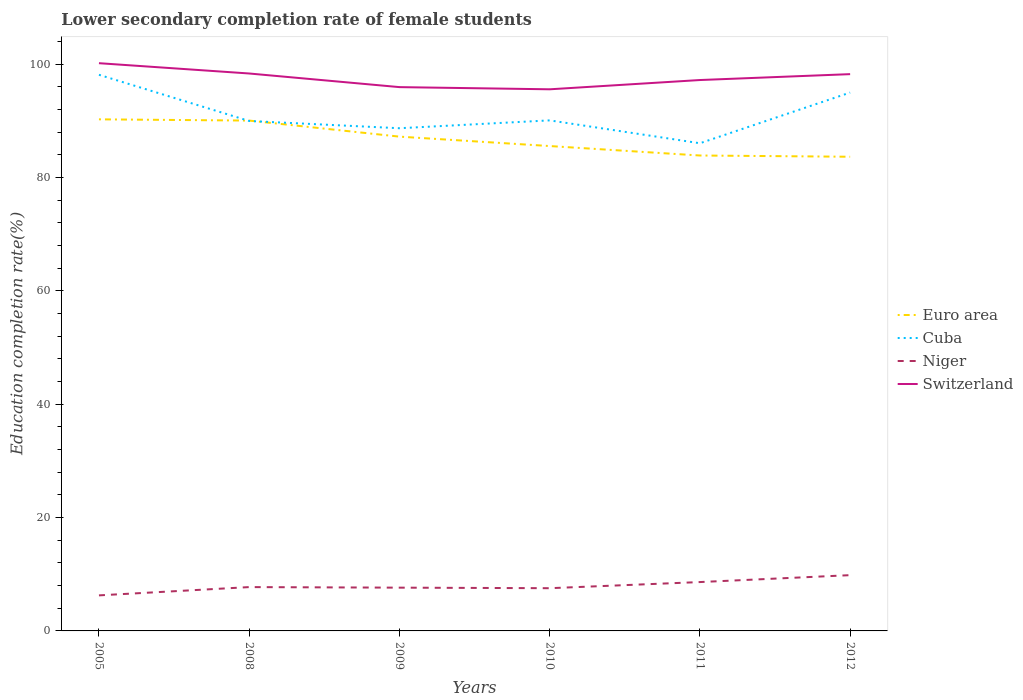How many different coloured lines are there?
Give a very brief answer. 4. Does the line corresponding to Cuba intersect with the line corresponding to Switzerland?
Your answer should be very brief. No. Is the number of lines equal to the number of legend labels?
Make the answer very short. Yes. Across all years, what is the maximum lower secondary completion rate of female students in Switzerland?
Your answer should be very brief. 95.54. In which year was the lower secondary completion rate of female students in Euro area maximum?
Your answer should be compact. 2012. What is the total lower secondary completion rate of female students in Cuba in the graph?
Your response must be concise. 2.65. What is the difference between the highest and the second highest lower secondary completion rate of female students in Niger?
Ensure brevity in your answer.  3.57. Does the graph contain any zero values?
Ensure brevity in your answer.  No. How many legend labels are there?
Your answer should be very brief. 4. What is the title of the graph?
Give a very brief answer. Lower secondary completion rate of female students. What is the label or title of the X-axis?
Provide a succinct answer. Years. What is the label or title of the Y-axis?
Provide a succinct answer. Education completion rate(%). What is the Education completion rate(%) in Euro area in 2005?
Make the answer very short. 90.25. What is the Education completion rate(%) of Cuba in 2005?
Offer a very short reply. 98.11. What is the Education completion rate(%) of Niger in 2005?
Offer a very short reply. 6.27. What is the Education completion rate(%) in Switzerland in 2005?
Your answer should be compact. 100.15. What is the Education completion rate(%) of Euro area in 2008?
Your answer should be compact. 90.03. What is the Education completion rate(%) in Cuba in 2008?
Your answer should be compact. 89.95. What is the Education completion rate(%) in Niger in 2008?
Your answer should be compact. 7.73. What is the Education completion rate(%) of Switzerland in 2008?
Offer a very short reply. 98.33. What is the Education completion rate(%) of Euro area in 2009?
Make the answer very short. 87.19. What is the Education completion rate(%) of Cuba in 2009?
Provide a short and direct response. 88.68. What is the Education completion rate(%) in Niger in 2009?
Your answer should be very brief. 7.63. What is the Education completion rate(%) in Switzerland in 2009?
Provide a succinct answer. 95.93. What is the Education completion rate(%) in Euro area in 2010?
Offer a very short reply. 85.53. What is the Education completion rate(%) in Cuba in 2010?
Ensure brevity in your answer.  90.06. What is the Education completion rate(%) in Niger in 2010?
Provide a succinct answer. 7.54. What is the Education completion rate(%) in Switzerland in 2010?
Make the answer very short. 95.54. What is the Education completion rate(%) in Euro area in 2011?
Your answer should be very brief. 83.87. What is the Education completion rate(%) of Cuba in 2011?
Your answer should be very brief. 86.03. What is the Education completion rate(%) in Niger in 2011?
Your answer should be compact. 8.62. What is the Education completion rate(%) in Switzerland in 2011?
Make the answer very short. 97.18. What is the Education completion rate(%) in Euro area in 2012?
Make the answer very short. 83.65. What is the Education completion rate(%) of Cuba in 2012?
Provide a short and direct response. 94.97. What is the Education completion rate(%) in Niger in 2012?
Provide a short and direct response. 9.84. What is the Education completion rate(%) of Switzerland in 2012?
Provide a succinct answer. 98.22. Across all years, what is the maximum Education completion rate(%) of Euro area?
Your answer should be very brief. 90.25. Across all years, what is the maximum Education completion rate(%) of Cuba?
Provide a short and direct response. 98.11. Across all years, what is the maximum Education completion rate(%) of Niger?
Provide a succinct answer. 9.84. Across all years, what is the maximum Education completion rate(%) of Switzerland?
Ensure brevity in your answer.  100.15. Across all years, what is the minimum Education completion rate(%) in Euro area?
Provide a short and direct response. 83.65. Across all years, what is the minimum Education completion rate(%) in Cuba?
Make the answer very short. 86.03. Across all years, what is the minimum Education completion rate(%) in Niger?
Offer a terse response. 6.27. Across all years, what is the minimum Education completion rate(%) of Switzerland?
Your response must be concise. 95.54. What is the total Education completion rate(%) in Euro area in the graph?
Offer a terse response. 520.51. What is the total Education completion rate(%) of Cuba in the graph?
Your response must be concise. 547.79. What is the total Education completion rate(%) in Niger in the graph?
Offer a very short reply. 47.63. What is the total Education completion rate(%) in Switzerland in the graph?
Provide a succinct answer. 585.35. What is the difference between the Education completion rate(%) in Euro area in 2005 and that in 2008?
Keep it short and to the point. 0.22. What is the difference between the Education completion rate(%) of Cuba in 2005 and that in 2008?
Ensure brevity in your answer.  8.15. What is the difference between the Education completion rate(%) of Niger in 2005 and that in 2008?
Ensure brevity in your answer.  -1.46. What is the difference between the Education completion rate(%) of Switzerland in 2005 and that in 2008?
Keep it short and to the point. 1.82. What is the difference between the Education completion rate(%) in Euro area in 2005 and that in 2009?
Offer a very short reply. 3.05. What is the difference between the Education completion rate(%) in Cuba in 2005 and that in 2009?
Ensure brevity in your answer.  9.43. What is the difference between the Education completion rate(%) of Niger in 2005 and that in 2009?
Provide a succinct answer. -1.36. What is the difference between the Education completion rate(%) in Switzerland in 2005 and that in 2009?
Provide a succinct answer. 4.22. What is the difference between the Education completion rate(%) of Euro area in 2005 and that in 2010?
Provide a short and direct response. 4.71. What is the difference between the Education completion rate(%) in Cuba in 2005 and that in 2010?
Provide a succinct answer. 8.04. What is the difference between the Education completion rate(%) of Niger in 2005 and that in 2010?
Your response must be concise. -1.27. What is the difference between the Education completion rate(%) in Switzerland in 2005 and that in 2010?
Provide a succinct answer. 4.61. What is the difference between the Education completion rate(%) in Euro area in 2005 and that in 2011?
Keep it short and to the point. 6.38. What is the difference between the Education completion rate(%) in Cuba in 2005 and that in 2011?
Your response must be concise. 12.08. What is the difference between the Education completion rate(%) in Niger in 2005 and that in 2011?
Keep it short and to the point. -2.35. What is the difference between the Education completion rate(%) of Switzerland in 2005 and that in 2011?
Give a very brief answer. 2.97. What is the difference between the Education completion rate(%) of Euro area in 2005 and that in 2012?
Your answer should be compact. 6.6. What is the difference between the Education completion rate(%) in Cuba in 2005 and that in 2012?
Your answer should be compact. 3.14. What is the difference between the Education completion rate(%) of Niger in 2005 and that in 2012?
Your answer should be very brief. -3.57. What is the difference between the Education completion rate(%) in Switzerland in 2005 and that in 2012?
Give a very brief answer. 1.93. What is the difference between the Education completion rate(%) of Euro area in 2008 and that in 2009?
Keep it short and to the point. 2.83. What is the difference between the Education completion rate(%) of Cuba in 2008 and that in 2009?
Make the answer very short. 1.28. What is the difference between the Education completion rate(%) of Niger in 2008 and that in 2009?
Offer a terse response. 0.1. What is the difference between the Education completion rate(%) of Switzerland in 2008 and that in 2009?
Your response must be concise. 2.4. What is the difference between the Education completion rate(%) in Euro area in 2008 and that in 2010?
Provide a succinct answer. 4.49. What is the difference between the Education completion rate(%) of Cuba in 2008 and that in 2010?
Make the answer very short. -0.11. What is the difference between the Education completion rate(%) of Niger in 2008 and that in 2010?
Make the answer very short. 0.2. What is the difference between the Education completion rate(%) in Switzerland in 2008 and that in 2010?
Ensure brevity in your answer.  2.79. What is the difference between the Education completion rate(%) of Euro area in 2008 and that in 2011?
Provide a short and direct response. 6.16. What is the difference between the Education completion rate(%) of Cuba in 2008 and that in 2011?
Provide a short and direct response. 3.93. What is the difference between the Education completion rate(%) of Niger in 2008 and that in 2011?
Give a very brief answer. -0.89. What is the difference between the Education completion rate(%) of Switzerland in 2008 and that in 2011?
Provide a short and direct response. 1.15. What is the difference between the Education completion rate(%) in Euro area in 2008 and that in 2012?
Keep it short and to the point. 6.38. What is the difference between the Education completion rate(%) of Cuba in 2008 and that in 2012?
Give a very brief answer. -5.01. What is the difference between the Education completion rate(%) of Niger in 2008 and that in 2012?
Your answer should be very brief. -2.11. What is the difference between the Education completion rate(%) of Switzerland in 2008 and that in 2012?
Provide a short and direct response. 0.11. What is the difference between the Education completion rate(%) in Euro area in 2009 and that in 2010?
Provide a succinct answer. 1.66. What is the difference between the Education completion rate(%) in Cuba in 2009 and that in 2010?
Provide a succinct answer. -1.39. What is the difference between the Education completion rate(%) in Niger in 2009 and that in 2010?
Provide a short and direct response. 0.1. What is the difference between the Education completion rate(%) of Switzerland in 2009 and that in 2010?
Give a very brief answer. 0.39. What is the difference between the Education completion rate(%) of Euro area in 2009 and that in 2011?
Provide a short and direct response. 3.33. What is the difference between the Education completion rate(%) of Cuba in 2009 and that in 2011?
Give a very brief answer. 2.65. What is the difference between the Education completion rate(%) in Niger in 2009 and that in 2011?
Provide a succinct answer. -0.99. What is the difference between the Education completion rate(%) in Switzerland in 2009 and that in 2011?
Provide a succinct answer. -1.25. What is the difference between the Education completion rate(%) of Euro area in 2009 and that in 2012?
Your response must be concise. 3.55. What is the difference between the Education completion rate(%) of Cuba in 2009 and that in 2012?
Your answer should be compact. -6.29. What is the difference between the Education completion rate(%) of Niger in 2009 and that in 2012?
Your response must be concise. -2.2. What is the difference between the Education completion rate(%) of Switzerland in 2009 and that in 2012?
Make the answer very short. -2.29. What is the difference between the Education completion rate(%) of Euro area in 2010 and that in 2011?
Provide a short and direct response. 1.67. What is the difference between the Education completion rate(%) of Cuba in 2010 and that in 2011?
Your response must be concise. 4.04. What is the difference between the Education completion rate(%) in Niger in 2010 and that in 2011?
Provide a short and direct response. -1.08. What is the difference between the Education completion rate(%) of Switzerland in 2010 and that in 2011?
Your answer should be compact. -1.64. What is the difference between the Education completion rate(%) of Euro area in 2010 and that in 2012?
Your response must be concise. 1.89. What is the difference between the Education completion rate(%) of Cuba in 2010 and that in 2012?
Make the answer very short. -4.91. What is the difference between the Education completion rate(%) of Niger in 2010 and that in 2012?
Offer a very short reply. -2.3. What is the difference between the Education completion rate(%) in Switzerland in 2010 and that in 2012?
Offer a terse response. -2.67. What is the difference between the Education completion rate(%) in Euro area in 2011 and that in 2012?
Your response must be concise. 0.22. What is the difference between the Education completion rate(%) in Cuba in 2011 and that in 2012?
Provide a short and direct response. -8.94. What is the difference between the Education completion rate(%) in Niger in 2011 and that in 2012?
Ensure brevity in your answer.  -1.22. What is the difference between the Education completion rate(%) in Switzerland in 2011 and that in 2012?
Provide a short and direct response. -1.04. What is the difference between the Education completion rate(%) of Euro area in 2005 and the Education completion rate(%) of Cuba in 2008?
Make the answer very short. 0.29. What is the difference between the Education completion rate(%) of Euro area in 2005 and the Education completion rate(%) of Niger in 2008?
Make the answer very short. 82.51. What is the difference between the Education completion rate(%) in Euro area in 2005 and the Education completion rate(%) in Switzerland in 2008?
Make the answer very short. -8.09. What is the difference between the Education completion rate(%) in Cuba in 2005 and the Education completion rate(%) in Niger in 2008?
Keep it short and to the point. 90.37. What is the difference between the Education completion rate(%) in Cuba in 2005 and the Education completion rate(%) in Switzerland in 2008?
Offer a terse response. -0.23. What is the difference between the Education completion rate(%) of Niger in 2005 and the Education completion rate(%) of Switzerland in 2008?
Ensure brevity in your answer.  -92.06. What is the difference between the Education completion rate(%) of Euro area in 2005 and the Education completion rate(%) of Cuba in 2009?
Provide a short and direct response. 1.57. What is the difference between the Education completion rate(%) of Euro area in 2005 and the Education completion rate(%) of Niger in 2009?
Your answer should be very brief. 82.61. What is the difference between the Education completion rate(%) in Euro area in 2005 and the Education completion rate(%) in Switzerland in 2009?
Your answer should be very brief. -5.68. What is the difference between the Education completion rate(%) in Cuba in 2005 and the Education completion rate(%) in Niger in 2009?
Keep it short and to the point. 90.47. What is the difference between the Education completion rate(%) of Cuba in 2005 and the Education completion rate(%) of Switzerland in 2009?
Your response must be concise. 2.18. What is the difference between the Education completion rate(%) in Niger in 2005 and the Education completion rate(%) in Switzerland in 2009?
Your response must be concise. -89.66. What is the difference between the Education completion rate(%) of Euro area in 2005 and the Education completion rate(%) of Cuba in 2010?
Offer a very short reply. 0.18. What is the difference between the Education completion rate(%) of Euro area in 2005 and the Education completion rate(%) of Niger in 2010?
Keep it short and to the point. 82.71. What is the difference between the Education completion rate(%) in Euro area in 2005 and the Education completion rate(%) in Switzerland in 2010?
Keep it short and to the point. -5.3. What is the difference between the Education completion rate(%) in Cuba in 2005 and the Education completion rate(%) in Niger in 2010?
Your response must be concise. 90.57. What is the difference between the Education completion rate(%) of Cuba in 2005 and the Education completion rate(%) of Switzerland in 2010?
Your response must be concise. 2.56. What is the difference between the Education completion rate(%) of Niger in 2005 and the Education completion rate(%) of Switzerland in 2010?
Provide a succinct answer. -89.27. What is the difference between the Education completion rate(%) in Euro area in 2005 and the Education completion rate(%) in Cuba in 2011?
Your answer should be compact. 4.22. What is the difference between the Education completion rate(%) in Euro area in 2005 and the Education completion rate(%) in Niger in 2011?
Offer a terse response. 81.63. What is the difference between the Education completion rate(%) in Euro area in 2005 and the Education completion rate(%) in Switzerland in 2011?
Your response must be concise. -6.93. What is the difference between the Education completion rate(%) in Cuba in 2005 and the Education completion rate(%) in Niger in 2011?
Make the answer very short. 89.49. What is the difference between the Education completion rate(%) in Cuba in 2005 and the Education completion rate(%) in Switzerland in 2011?
Your answer should be very brief. 0.93. What is the difference between the Education completion rate(%) of Niger in 2005 and the Education completion rate(%) of Switzerland in 2011?
Your response must be concise. -90.91. What is the difference between the Education completion rate(%) in Euro area in 2005 and the Education completion rate(%) in Cuba in 2012?
Your response must be concise. -4.72. What is the difference between the Education completion rate(%) in Euro area in 2005 and the Education completion rate(%) in Niger in 2012?
Make the answer very short. 80.41. What is the difference between the Education completion rate(%) in Euro area in 2005 and the Education completion rate(%) in Switzerland in 2012?
Keep it short and to the point. -7.97. What is the difference between the Education completion rate(%) in Cuba in 2005 and the Education completion rate(%) in Niger in 2012?
Your response must be concise. 88.27. What is the difference between the Education completion rate(%) in Cuba in 2005 and the Education completion rate(%) in Switzerland in 2012?
Ensure brevity in your answer.  -0.11. What is the difference between the Education completion rate(%) in Niger in 2005 and the Education completion rate(%) in Switzerland in 2012?
Your answer should be compact. -91.95. What is the difference between the Education completion rate(%) in Euro area in 2008 and the Education completion rate(%) in Cuba in 2009?
Provide a short and direct response. 1.35. What is the difference between the Education completion rate(%) in Euro area in 2008 and the Education completion rate(%) in Niger in 2009?
Offer a very short reply. 82.39. What is the difference between the Education completion rate(%) in Euro area in 2008 and the Education completion rate(%) in Switzerland in 2009?
Give a very brief answer. -5.9. What is the difference between the Education completion rate(%) of Cuba in 2008 and the Education completion rate(%) of Niger in 2009?
Give a very brief answer. 82.32. What is the difference between the Education completion rate(%) in Cuba in 2008 and the Education completion rate(%) in Switzerland in 2009?
Keep it short and to the point. -5.97. What is the difference between the Education completion rate(%) of Niger in 2008 and the Education completion rate(%) of Switzerland in 2009?
Your answer should be compact. -88.2. What is the difference between the Education completion rate(%) of Euro area in 2008 and the Education completion rate(%) of Cuba in 2010?
Your answer should be very brief. -0.04. What is the difference between the Education completion rate(%) in Euro area in 2008 and the Education completion rate(%) in Niger in 2010?
Offer a very short reply. 82.49. What is the difference between the Education completion rate(%) in Euro area in 2008 and the Education completion rate(%) in Switzerland in 2010?
Your answer should be very brief. -5.52. What is the difference between the Education completion rate(%) in Cuba in 2008 and the Education completion rate(%) in Niger in 2010?
Keep it short and to the point. 82.42. What is the difference between the Education completion rate(%) in Cuba in 2008 and the Education completion rate(%) in Switzerland in 2010?
Keep it short and to the point. -5.59. What is the difference between the Education completion rate(%) in Niger in 2008 and the Education completion rate(%) in Switzerland in 2010?
Give a very brief answer. -87.81. What is the difference between the Education completion rate(%) in Euro area in 2008 and the Education completion rate(%) in Niger in 2011?
Ensure brevity in your answer.  81.41. What is the difference between the Education completion rate(%) in Euro area in 2008 and the Education completion rate(%) in Switzerland in 2011?
Your response must be concise. -7.15. What is the difference between the Education completion rate(%) of Cuba in 2008 and the Education completion rate(%) of Niger in 2011?
Your response must be concise. 81.34. What is the difference between the Education completion rate(%) of Cuba in 2008 and the Education completion rate(%) of Switzerland in 2011?
Keep it short and to the point. -7.22. What is the difference between the Education completion rate(%) in Niger in 2008 and the Education completion rate(%) in Switzerland in 2011?
Make the answer very short. -89.45. What is the difference between the Education completion rate(%) of Euro area in 2008 and the Education completion rate(%) of Cuba in 2012?
Make the answer very short. -4.94. What is the difference between the Education completion rate(%) of Euro area in 2008 and the Education completion rate(%) of Niger in 2012?
Provide a succinct answer. 80.19. What is the difference between the Education completion rate(%) in Euro area in 2008 and the Education completion rate(%) in Switzerland in 2012?
Your response must be concise. -8.19. What is the difference between the Education completion rate(%) of Cuba in 2008 and the Education completion rate(%) of Niger in 2012?
Ensure brevity in your answer.  80.12. What is the difference between the Education completion rate(%) in Cuba in 2008 and the Education completion rate(%) in Switzerland in 2012?
Offer a very short reply. -8.26. What is the difference between the Education completion rate(%) in Niger in 2008 and the Education completion rate(%) in Switzerland in 2012?
Your answer should be very brief. -90.49. What is the difference between the Education completion rate(%) in Euro area in 2009 and the Education completion rate(%) in Cuba in 2010?
Your answer should be very brief. -2.87. What is the difference between the Education completion rate(%) in Euro area in 2009 and the Education completion rate(%) in Niger in 2010?
Offer a very short reply. 79.66. What is the difference between the Education completion rate(%) of Euro area in 2009 and the Education completion rate(%) of Switzerland in 2010?
Ensure brevity in your answer.  -8.35. What is the difference between the Education completion rate(%) in Cuba in 2009 and the Education completion rate(%) in Niger in 2010?
Make the answer very short. 81.14. What is the difference between the Education completion rate(%) of Cuba in 2009 and the Education completion rate(%) of Switzerland in 2010?
Ensure brevity in your answer.  -6.87. What is the difference between the Education completion rate(%) in Niger in 2009 and the Education completion rate(%) in Switzerland in 2010?
Ensure brevity in your answer.  -87.91. What is the difference between the Education completion rate(%) in Euro area in 2009 and the Education completion rate(%) in Cuba in 2011?
Provide a short and direct response. 1.17. What is the difference between the Education completion rate(%) in Euro area in 2009 and the Education completion rate(%) in Niger in 2011?
Your answer should be compact. 78.57. What is the difference between the Education completion rate(%) of Euro area in 2009 and the Education completion rate(%) of Switzerland in 2011?
Make the answer very short. -9.98. What is the difference between the Education completion rate(%) in Cuba in 2009 and the Education completion rate(%) in Niger in 2011?
Ensure brevity in your answer.  80.06. What is the difference between the Education completion rate(%) of Cuba in 2009 and the Education completion rate(%) of Switzerland in 2011?
Your answer should be very brief. -8.5. What is the difference between the Education completion rate(%) in Niger in 2009 and the Education completion rate(%) in Switzerland in 2011?
Give a very brief answer. -89.54. What is the difference between the Education completion rate(%) in Euro area in 2009 and the Education completion rate(%) in Cuba in 2012?
Provide a succinct answer. -7.77. What is the difference between the Education completion rate(%) of Euro area in 2009 and the Education completion rate(%) of Niger in 2012?
Keep it short and to the point. 77.36. What is the difference between the Education completion rate(%) in Euro area in 2009 and the Education completion rate(%) in Switzerland in 2012?
Make the answer very short. -11.02. What is the difference between the Education completion rate(%) in Cuba in 2009 and the Education completion rate(%) in Niger in 2012?
Make the answer very short. 78.84. What is the difference between the Education completion rate(%) of Cuba in 2009 and the Education completion rate(%) of Switzerland in 2012?
Give a very brief answer. -9.54. What is the difference between the Education completion rate(%) of Niger in 2009 and the Education completion rate(%) of Switzerland in 2012?
Provide a succinct answer. -90.58. What is the difference between the Education completion rate(%) in Euro area in 2010 and the Education completion rate(%) in Cuba in 2011?
Offer a very short reply. -0.49. What is the difference between the Education completion rate(%) of Euro area in 2010 and the Education completion rate(%) of Niger in 2011?
Your answer should be very brief. 76.91. What is the difference between the Education completion rate(%) of Euro area in 2010 and the Education completion rate(%) of Switzerland in 2011?
Give a very brief answer. -11.64. What is the difference between the Education completion rate(%) in Cuba in 2010 and the Education completion rate(%) in Niger in 2011?
Ensure brevity in your answer.  81.44. What is the difference between the Education completion rate(%) in Cuba in 2010 and the Education completion rate(%) in Switzerland in 2011?
Give a very brief answer. -7.12. What is the difference between the Education completion rate(%) of Niger in 2010 and the Education completion rate(%) of Switzerland in 2011?
Provide a short and direct response. -89.64. What is the difference between the Education completion rate(%) in Euro area in 2010 and the Education completion rate(%) in Cuba in 2012?
Provide a short and direct response. -9.43. What is the difference between the Education completion rate(%) in Euro area in 2010 and the Education completion rate(%) in Niger in 2012?
Provide a short and direct response. 75.7. What is the difference between the Education completion rate(%) in Euro area in 2010 and the Education completion rate(%) in Switzerland in 2012?
Offer a very short reply. -12.68. What is the difference between the Education completion rate(%) in Cuba in 2010 and the Education completion rate(%) in Niger in 2012?
Offer a terse response. 80.22. What is the difference between the Education completion rate(%) of Cuba in 2010 and the Education completion rate(%) of Switzerland in 2012?
Make the answer very short. -8.16. What is the difference between the Education completion rate(%) of Niger in 2010 and the Education completion rate(%) of Switzerland in 2012?
Offer a terse response. -90.68. What is the difference between the Education completion rate(%) in Euro area in 2011 and the Education completion rate(%) in Cuba in 2012?
Your answer should be compact. -11.1. What is the difference between the Education completion rate(%) in Euro area in 2011 and the Education completion rate(%) in Niger in 2012?
Provide a succinct answer. 74.03. What is the difference between the Education completion rate(%) in Euro area in 2011 and the Education completion rate(%) in Switzerland in 2012?
Your response must be concise. -14.35. What is the difference between the Education completion rate(%) in Cuba in 2011 and the Education completion rate(%) in Niger in 2012?
Your answer should be very brief. 76.19. What is the difference between the Education completion rate(%) in Cuba in 2011 and the Education completion rate(%) in Switzerland in 2012?
Offer a very short reply. -12.19. What is the difference between the Education completion rate(%) of Niger in 2011 and the Education completion rate(%) of Switzerland in 2012?
Provide a succinct answer. -89.6. What is the average Education completion rate(%) in Euro area per year?
Provide a short and direct response. 86.75. What is the average Education completion rate(%) of Cuba per year?
Provide a short and direct response. 91.3. What is the average Education completion rate(%) of Niger per year?
Provide a succinct answer. 7.94. What is the average Education completion rate(%) in Switzerland per year?
Offer a very short reply. 97.56. In the year 2005, what is the difference between the Education completion rate(%) in Euro area and Education completion rate(%) in Cuba?
Provide a succinct answer. -7.86. In the year 2005, what is the difference between the Education completion rate(%) of Euro area and Education completion rate(%) of Niger?
Your answer should be compact. 83.97. In the year 2005, what is the difference between the Education completion rate(%) in Euro area and Education completion rate(%) in Switzerland?
Give a very brief answer. -9.91. In the year 2005, what is the difference between the Education completion rate(%) of Cuba and Education completion rate(%) of Niger?
Provide a succinct answer. 91.83. In the year 2005, what is the difference between the Education completion rate(%) of Cuba and Education completion rate(%) of Switzerland?
Provide a short and direct response. -2.05. In the year 2005, what is the difference between the Education completion rate(%) in Niger and Education completion rate(%) in Switzerland?
Offer a very short reply. -93.88. In the year 2008, what is the difference between the Education completion rate(%) of Euro area and Education completion rate(%) of Cuba?
Provide a short and direct response. 0.07. In the year 2008, what is the difference between the Education completion rate(%) in Euro area and Education completion rate(%) in Niger?
Your response must be concise. 82.29. In the year 2008, what is the difference between the Education completion rate(%) in Euro area and Education completion rate(%) in Switzerland?
Make the answer very short. -8.31. In the year 2008, what is the difference between the Education completion rate(%) of Cuba and Education completion rate(%) of Niger?
Your answer should be compact. 82.22. In the year 2008, what is the difference between the Education completion rate(%) in Cuba and Education completion rate(%) in Switzerland?
Keep it short and to the point. -8.38. In the year 2008, what is the difference between the Education completion rate(%) of Niger and Education completion rate(%) of Switzerland?
Offer a very short reply. -90.6. In the year 2009, what is the difference between the Education completion rate(%) of Euro area and Education completion rate(%) of Cuba?
Make the answer very short. -1.48. In the year 2009, what is the difference between the Education completion rate(%) of Euro area and Education completion rate(%) of Niger?
Offer a terse response. 79.56. In the year 2009, what is the difference between the Education completion rate(%) of Euro area and Education completion rate(%) of Switzerland?
Your answer should be compact. -8.73. In the year 2009, what is the difference between the Education completion rate(%) in Cuba and Education completion rate(%) in Niger?
Offer a very short reply. 81.04. In the year 2009, what is the difference between the Education completion rate(%) in Cuba and Education completion rate(%) in Switzerland?
Ensure brevity in your answer.  -7.25. In the year 2009, what is the difference between the Education completion rate(%) in Niger and Education completion rate(%) in Switzerland?
Offer a very short reply. -88.29. In the year 2010, what is the difference between the Education completion rate(%) of Euro area and Education completion rate(%) of Cuba?
Offer a very short reply. -4.53. In the year 2010, what is the difference between the Education completion rate(%) of Euro area and Education completion rate(%) of Niger?
Provide a succinct answer. 78. In the year 2010, what is the difference between the Education completion rate(%) of Euro area and Education completion rate(%) of Switzerland?
Provide a succinct answer. -10.01. In the year 2010, what is the difference between the Education completion rate(%) of Cuba and Education completion rate(%) of Niger?
Ensure brevity in your answer.  82.53. In the year 2010, what is the difference between the Education completion rate(%) in Cuba and Education completion rate(%) in Switzerland?
Provide a short and direct response. -5.48. In the year 2010, what is the difference between the Education completion rate(%) in Niger and Education completion rate(%) in Switzerland?
Your response must be concise. -88.01. In the year 2011, what is the difference between the Education completion rate(%) in Euro area and Education completion rate(%) in Cuba?
Make the answer very short. -2.16. In the year 2011, what is the difference between the Education completion rate(%) in Euro area and Education completion rate(%) in Niger?
Ensure brevity in your answer.  75.25. In the year 2011, what is the difference between the Education completion rate(%) of Euro area and Education completion rate(%) of Switzerland?
Your answer should be compact. -13.31. In the year 2011, what is the difference between the Education completion rate(%) in Cuba and Education completion rate(%) in Niger?
Your answer should be compact. 77.41. In the year 2011, what is the difference between the Education completion rate(%) in Cuba and Education completion rate(%) in Switzerland?
Give a very brief answer. -11.15. In the year 2011, what is the difference between the Education completion rate(%) in Niger and Education completion rate(%) in Switzerland?
Your answer should be compact. -88.56. In the year 2012, what is the difference between the Education completion rate(%) in Euro area and Education completion rate(%) in Cuba?
Ensure brevity in your answer.  -11.32. In the year 2012, what is the difference between the Education completion rate(%) in Euro area and Education completion rate(%) in Niger?
Your answer should be compact. 73.81. In the year 2012, what is the difference between the Education completion rate(%) of Euro area and Education completion rate(%) of Switzerland?
Your answer should be compact. -14.57. In the year 2012, what is the difference between the Education completion rate(%) of Cuba and Education completion rate(%) of Niger?
Make the answer very short. 85.13. In the year 2012, what is the difference between the Education completion rate(%) of Cuba and Education completion rate(%) of Switzerland?
Offer a very short reply. -3.25. In the year 2012, what is the difference between the Education completion rate(%) of Niger and Education completion rate(%) of Switzerland?
Offer a very short reply. -88.38. What is the ratio of the Education completion rate(%) of Cuba in 2005 to that in 2008?
Provide a short and direct response. 1.09. What is the ratio of the Education completion rate(%) of Niger in 2005 to that in 2008?
Offer a very short reply. 0.81. What is the ratio of the Education completion rate(%) in Switzerland in 2005 to that in 2008?
Offer a terse response. 1.02. What is the ratio of the Education completion rate(%) of Euro area in 2005 to that in 2009?
Your answer should be very brief. 1.03. What is the ratio of the Education completion rate(%) of Cuba in 2005 to that in 2009?
Ensure brevity in your answer.  1.11. What is the ratio of the Education completion rate(%) in Niger in 2005 to that in 2009?
Keep it short and to the point. 0.82. What is the ratio of the Education completion rate(%) of Switzerland in 2005 to that in 2009?
Keep it short and to the point. 1.04. What is the ratio of the Education completion rate(%) of Euro area in 2005 to that in 2010?
Provide a succinct answer. 1.06. What is the ratio of the Education completion rate(%) of Cuba in 2005 to that in 2010?
Give a very brief answer. 1.09. What is the ratio of the Education completion rate(%) of Niger in 2005 to that in 2010?
Provide a short and direct response. 0.83. What is the ratio of the Education completion rate(%) of Switzerland in 2005 to that in 2010?
Your response must be concise. 1.05. What is the ratio of the Education completion rate(%) in Euro area in 2005 to that in 2011?
Ensure brevity in your answer.  1.08. What is the ratio of the Education completion rate(%) of Cuba in 2005 to that in 2011?
Give a very brief answer. 1.14. What is the ratio of the Education completion rate(%) in Niger in 2005 to that in 2011?
Make the answer very short. 0.73. What is the ratio of the Education completion rate(%) of Switzerland in 2005 to that in 2011?
Provide a succinct answer. 1.03. What is the ratio of the Education completion rate(%) in Euro area in 2005 to that in 2012?
Your answer should be compact. 1.08. What is the ratio of the Education completion rate(%) in Cuba in 2005 to that in 2012?
Offer a terse response. 1.03. What is the ratio of the Education completion rate(%) of Niger in 2005 to that in 2012?
Give a very brief answer. 0.64. What is the ratio of the Education completion rate(%) in Switzerland in 2005 to that in 2012?
Keep it short and to the point. 1.02. What is the ratio of the Education completion rate(%) of Euro area in 2008 to that in 2009?
Your response must be concise. 1.03. What is the ratio of the Education completion rate(%) of Cuba in 2008 to that in 2009?
Ensure brevity in your answer.  1.01. What is the ratio of the Education completion rate(%) in Niger in 2008 to that in 2009?
Make the answer very short. 1.01. What is the ratio of the Education completion rate(%) of Switzerland in 2008 to that in 2009?
Ensure brevity in your answer.  1.03. What is the ratio of the Education completion rate(%) in Euro area in 2008 to that in 2010?
Provide a short and direct response. 1.05. What is the ratio of the Education completion rate(%) of Niger in 2008 to that in 2010?
Ensure brevity in your answer.  1.03. What is the ratio of the Education completion rate(%) in Switzerland in 2008 to that in 2010?
Give a very brief answer. 1.03. What is the ratio of the Education completion rate(%) of Euro area in 2008 to that in 2011?
Ensure brevity in your answer.  1.07. What is the ratio of the Education completion rate(%) of Cuba in 2008 to that in 2011?
Provide a succinct answer. 1.05. What is the ratio of the Education completion rate(%) of Niger in 2008 to that in 2011?
Give a very brief answer. 0.9. What is the ratio of the Education completion rate(%) of Switzerland in 2008 to that in 2011?
Offer a very short reply. 1.01. What is the ratio of the Education completion rate(%) in Euro area in 2008 to that in 2012?
Offer a very short reply. 1.08. What is the ratio of the Education completion rate(%) of Cuba in 2008 to that in 2012?
Your answer should be very brief. 0.95. What is the ratio of the Education completion rate(%) of Niger in 2008 to that in 2012?
Keep it short and to the point. 0.79. What is the ratio of the Education completion rate(%) of Switzerland in 2008 to that in 2012?
Keep it short and to the point. 1. What is the ratio of the Education completion rate(%) in Euro area in 2009 to that in 2010?
Ensure brevity in your answer.  1.02. What is the ratio of the Education completion rate(%) of Cuba in 2009 to that in 2010?
Ensure brevity in your answer.  0.98. What is the ratio of the Education completion rate(%) of Niger in 2009 to that in 2010?
Give a very brief answer. 1.01. What is the ratio of the Education completion rate(%) in Euro area in 2009 to that in 2011?
Your answer should be very brief. 1.04. What is the ratio of the Education completion rate(%) in Cuba in 2009 to that in 2011?
Your answer should be compact. 1.03. What is the ratio of the Education completion rate(%) of Niger in 2009 to that in 2011?
Offer a very short reply. 0.89. What is the ratio of the Education completion rate(%) of Switzerland in 2009 to that in 2011?
Your answer should be very brief. 0.99. What is the ratio of the Education completion rate(%) of Euro area in 2009 to that in 2012?
Provide a short and direct response. 1.04. What is the ratio of the Education completion rate(%) in Cuba in 2009 to that in 2012?
Make the answer very short. 0.93. What is the ratio of the Education completion rate(%) of Niger in 2009 to that in 2012?
Make the answer very short. 0.78. What is the ratio of the Education completion rate(%) of Switzerland in 2009 to that in 2012?
Your answer should be very brief. 0.98. What is the ratio of the Education completion rate(%) in Euro area in 2010 to that in 2011?
Keep it short and to the point. 1.02. What is the ratio of the Education completion rate(%) of Cuba in 2010 to that in 2011?
Make the answer very short. 1.05. What is the ratio of the Education completion rate(%) in Niger in 2010 to that in 2011?
Keep it short and to the point. 0.87. What is the ratio of the Education completion rate(%) of Switzerland in 2010 to that in 2011?
Your answer should be very brief. 0.98. What is the ratio of the Education completion rate(%) of Euro area in 2010 to that in 2012?
Give a very brief answer. 1.02. What is the ratio of the Education completion rate(%) of Cuba in 2010 to that in 2012?
Make the answer very short. 0.95. What is the ratio of the Education completion rate(%) in Niger in 2010 to that in 2012?
Offer a terse response. 0.77. What is the ratio of the Education completion rate(%) of Switzerland in 2010 to that in 2012?
Make the answer very short. 0.97. What is the ratio of the Education completion rate(%) in Cuba in 2011 to that in 2012?
Offer a terse response. 0.91. What is the ratio of the Education completion rate(%) of Niger in 2011 to that in 2012?
Ensure brevity in your answer.  0.88. What is the ratio of the Education completion rate(%) in Switzerland in 2011 to that in 2012?
Your response must be concise. 0.99. What is the difference between the highest and the second highest Education completion rate(%) in Euro area?
Your answer should be compact. 0.22. What is the difference between the highest and the second highest Education completion rate(%) in Cuba?
Your answer should be very brief. 3.14. What is the difference between the highest and the second highest Education completion rate(%) of Niger?
Give a very brief answer. 1.22. What is the difference between the highest and the second highest Education completion rate(%) of Switzerland?
Your response must be concise. 1.82. What is the difference between the highest and the lowest Education completion rate(%) of Euro area?
Make the answer very short. 6.6. What is the difference between the highest and the lowest Education completion rate(%) in Cuba?
Your answer should be compact. 12.08. What is the difference between the highest and the lowest Education completion rate(%) of Niger?
Make the answer very short. 3.57. What is the difference between the highest and the lowest Education completion rate(%) of Switzerland?
Give a very brief answer. 4.61. 